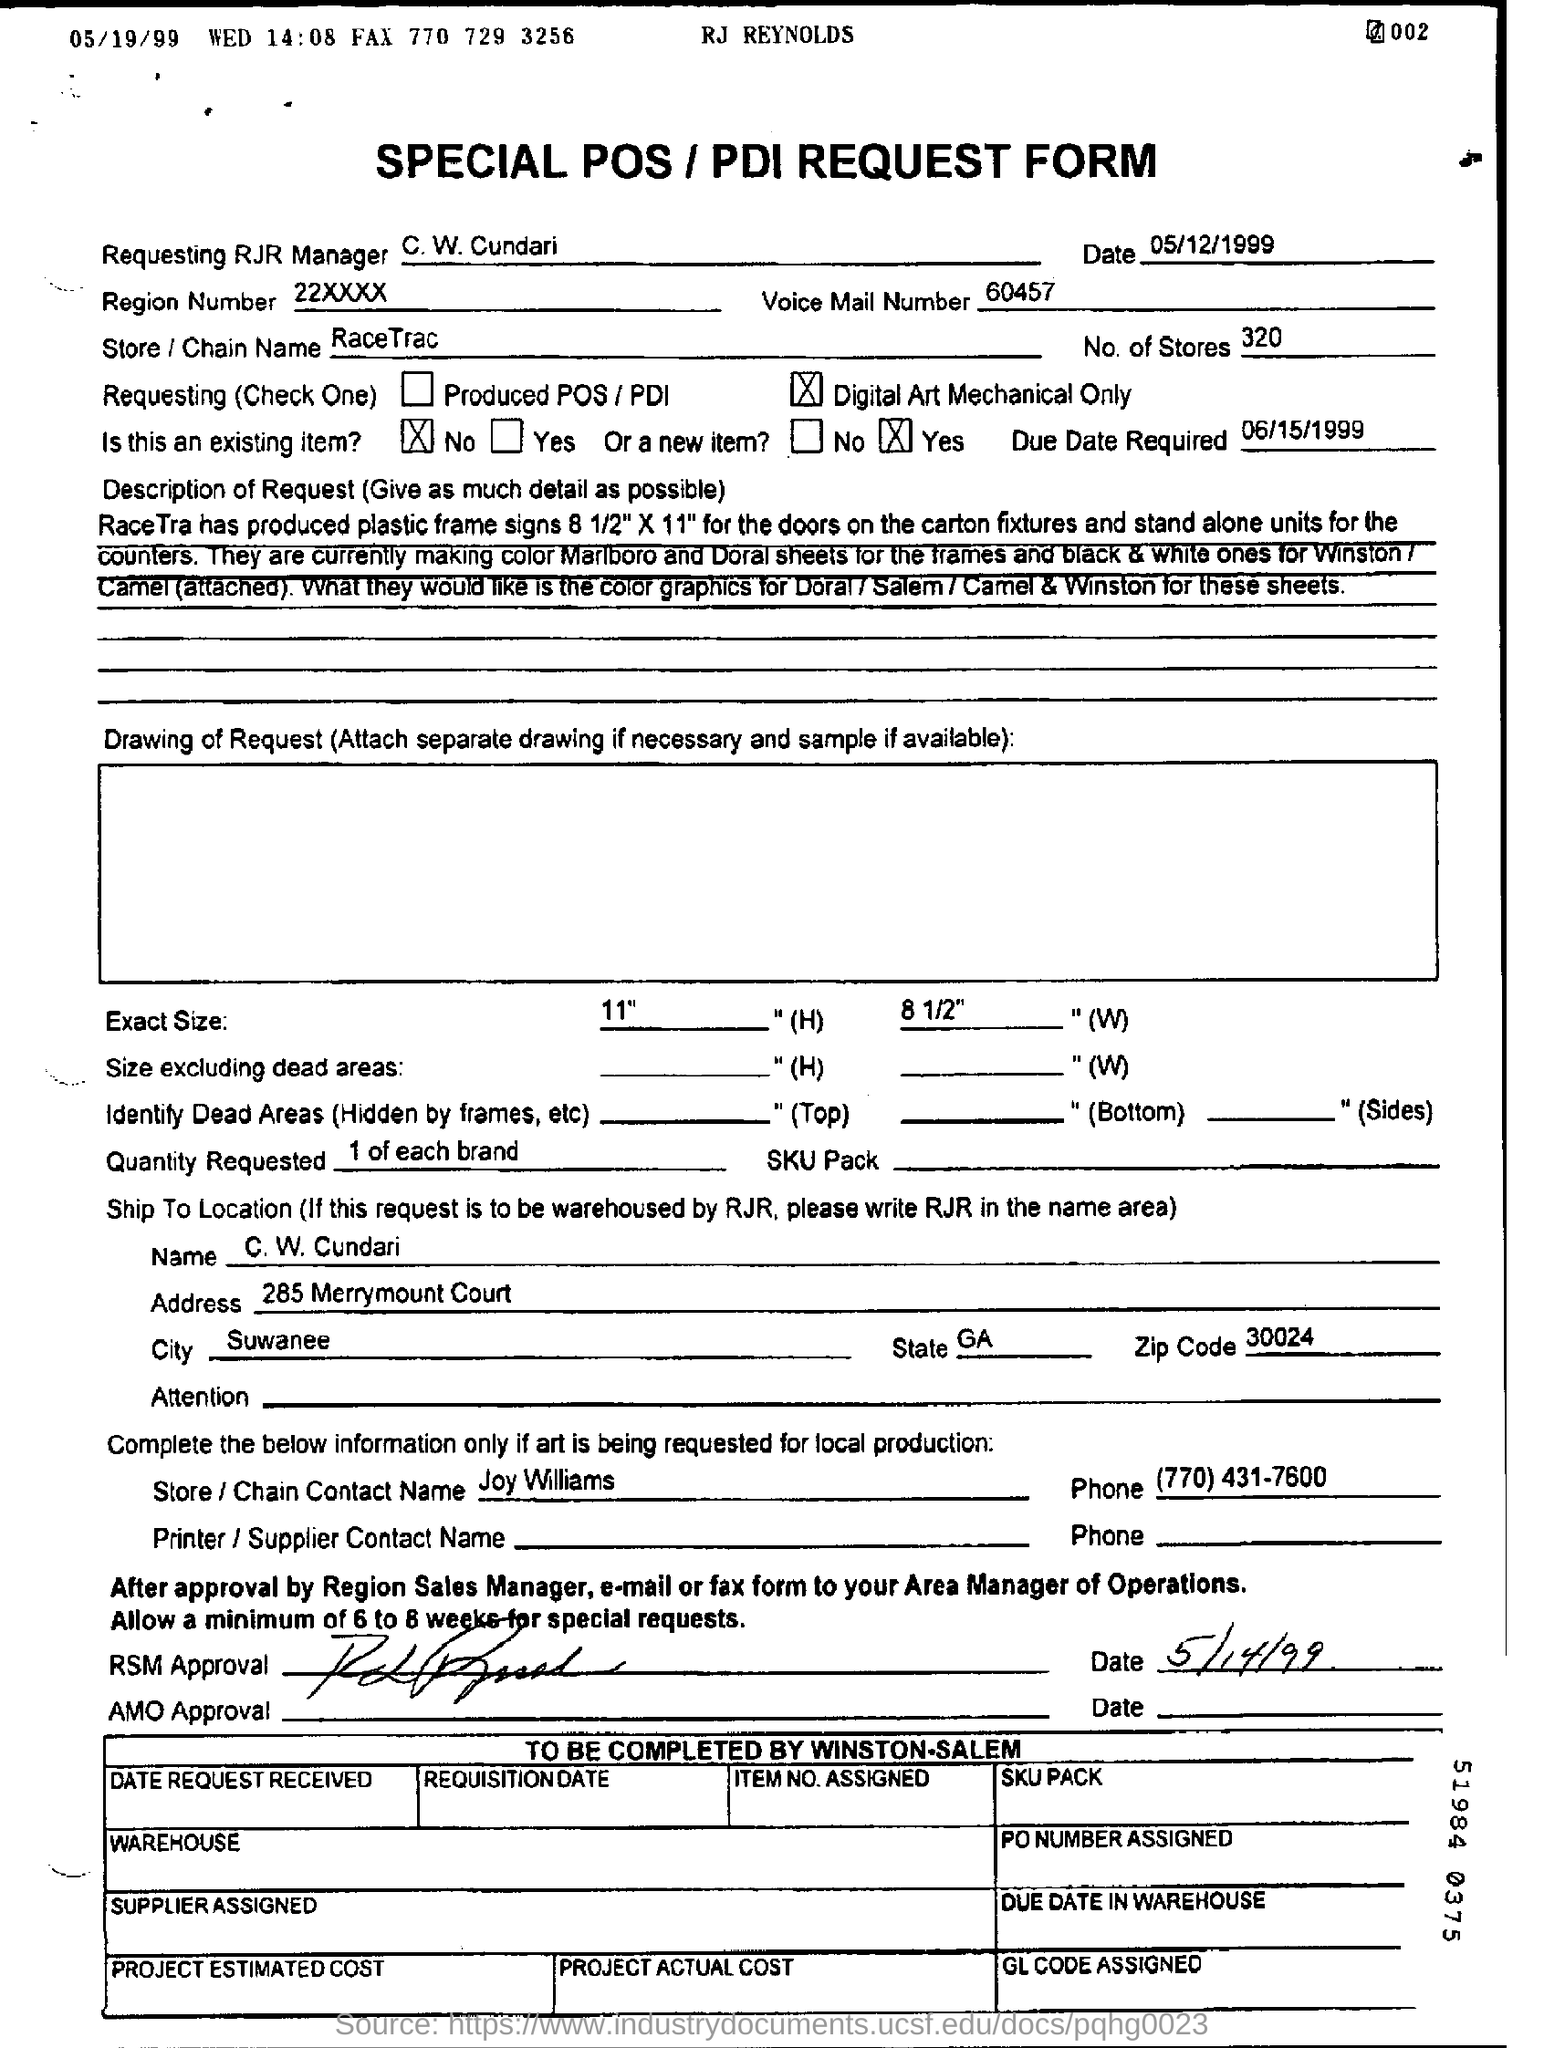Indicate a few pertinent items in this graphic. The name of the contact at the store/chain is Joy Williams. The form is dated as of May 12, 1999. The store/chain name is RaceTrac. The region number is 22XXXX.. The voice mail number is 60457... 